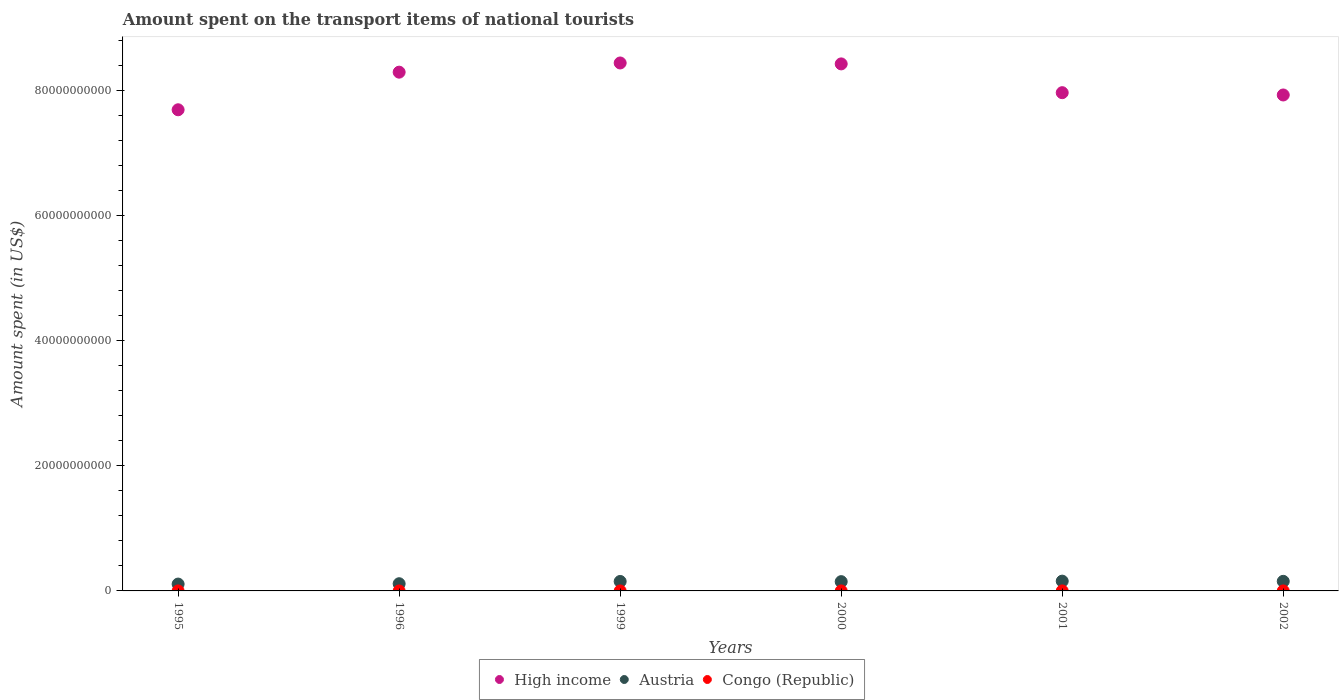How many different coloured dotlines are there?
Provide a short and direct response. 3. What is the amount spent on the transport items of national tourists in Austria in 2001?
Provide a succinct answer. 1.56e+09. Across all years, what is the maximum amount spent on the transport items of national tourists in Congo (Republic)?
Keep it short and to the point. 6.69e+05. Across all years, what is the minimum amount spent on the transport items of national tourists in Austria?
Provide a short and direct response. 1.09e+09. What is the total amount spent on the transport items of national tourists in Austria in the graph?
Your answer should be compact. 8.33e+09. What is the difference between the amount spent on the transport items of national tourists in High income in 1996 and that in 2001?
Your response must be concise. 3.28e+09. What is the difference between the amount spent on the transport items of national tourists in Congo (Republic) in 1999 and the amount spent on the transport items of national tourists in High income in 1996?
Ensure brevity in your answer.  -8.29e+1. What is the average amount spent on the transport items of national tourists in Austria per year?
Ensure brevity in your answer.  1.39e+09. In the year 1999, what is the difference between the amount spent on the transport items of national tourists in Austria and amount spent on the transport items of national tourists in Congo (Republic)?
Make the answer very short. 1.51e+09. What is the ratio of the amount spent on the transport items of national tourists in Austria in 1999 to that in 2000?
Keep it short and to the point. 1.02. What is the difference between the highest and the second highest amount spent on the transport items of national tourists in Congo (Republic)?
Make the answer very short. 6.91e+04. What is the difference between the highest and the lowest amount spent on the transport items of national tourists in High income?
Give a very brief answer. 7.48e+09. Is the sum of the amount spent on the transport items of national tourists in High income in 1996 and 1999 greater than the maximum amount spent on the transport items of national tourists in Congo (Republic) across all years?
Provide a succinct answer. Yes. Is the amount spent on the transport items of national tourists in High income strictly less than the amount spent on the transport items of national tourists in Congo (Republic) over the years?
Offer a terse response. No. Are the values on the major ticks of Y-axis written in scientific E-notation?
Provide a short and direct response. No. Does the graph contain any zero values?
Keep it short and to the point. No. Does the graph contain grids?
Provide a succinct answer. No. Where does the legend appear in the graph?
Make the answer very short. Bottom center. How many legend labels are there?
Ensure brevity in your answer.  3. How are the legend labels stacked?
Provide a short and direct response. Horizontal. What is the title of the graph?
Your answer should be very brief. Amount spent on the transport items of national tourists. Does "Faeroe Islands" appear as one of the legend labels in the graph?
Give a very brief answer. No. What is the label or title of the X-axis?
Provide a succinct answer. Years. What is the label or title of the Y-axis?
Offer a very short reply. Amount spent (in US$). What is the Amount spent (in US$) in High income in 1995?
Ensure brevity in your answer.  7.69e+1. What is the Amount spent (in US$) of Austria in 1995?
Give a very brief answer. 1.09e+09. What is the Amount spent (in US$) of Congo (Republic) in 1995?
Provide a short and direct response. 6.69e+05. What is the Amount spent (in US$) in High income in 1996?
Your answer should be very brief. 8.29e+1. What is the Amount spent (in US$) of Austria in 1996?
Ensure brevity in your answer.  1.15e+09. What is the Amount spent (in US$) of Congo (Republic) in 1996?
Offer a terse response. 1.76e+04. What is the Amount spent (in US$) in High income in 1999?
Keep it short and to the point. 8.44e+1. What is the Amount spent (in US$) of Austria in 1999?
Your response must be concise. 1.51e+09. What is the Amount spent (in US$) of Congo (Republic) in 1999?
Offer a terse response. 5.00e+05. What is the Amount spent (in US$) in High income in 2000?
Give a very brief answer. 8.42e+1. What is the Amount spent (in US$) in Austria in 2000?
Keep it short and to the point. 1.48e+09. What is the Amount spent (in US$) of High income in 2001?
Your answer should be very brief. 7.96e+1. What is the Amount spent (in US$) of Austria in 2001?
Offer a very short reply. 1.56e+09. What is the Amount spent (in US$) of Congo (Republic) in 2001?
Ensure brevity in your answer.  6.00e+05. What is the Amount spent (in US$) in High income in 2002?
Your answer should be very brief. 7.93e+1. What is the Amount spent (in US$) in Austria in 2002?
Make the answer very short. 1.53e+09. What is the Amount spent (in US$) in Congo (Republic) in 2002?
Give a very brief answer. 6.00e+05. Across all years, what is the maximum Amount spent (in US$) in High income?
Provide a succinct answer. 8.44e+1. Across all years, what is the maximum Amount spent (in US$) in Austria?
Make the answer very short. 1.56e+09. Across all years, what is the maximum Amount spent (in US$) of Congo (Republic)?
Give a very brief answer. 6.69e+05. Across all years, what is the minimum Amount spent (in US$) in High income?
Ensure brevity in your answer.  7.69e+1. Across all years, what is the minimum Amount spent (in US$) of Austria?
Keep it short and to the point. 1.09e+09. Across all years, what is the minimum Amount spent (in US$) of Congo (Republic)?
Your response must be concise. 1.76e+04. What is the total Amount spent (in US$) in High income in the graph?
Keep it short and to the point. 4.87e+11. What is the total Amount spent (in US$) of Austria in the graph?
Keep it short and to the point. 8.33e+09. What is the total Amount spent (in US$) of Congo (Republic) in the graph?
Keep it short and to the point. 2.79e+06. What is the difference between the Amount spent (in US$) of High income in 1995 and that in 1996?
Offer a terse response. -6.01e+09. What is the difference between the Amount spent (in US$) of Austria in 1995 and that in 1996?
Give a very brief answer. -5.60e+07. What is the difference between the Amount spent (in US$) in Congo (Republic) in 1995 and that in 1996?
Your response must be concise. 6.52e+05. What is the difference between the Amount spent (in US$) in High income in 1995 and that in 1999?
Keep it short and to the point. -7.48e+09. What is the difference between the Amount spent (in US$) of Austria in 1995 and that in 1999?
Give a very brief answer. -4.17e+08. What is the difference between the Amount spent (in US$) in Congo (Republic) in 1995 and that in 1999?
Provide a short and direct response. 1.69e+05. What is the difference between the Amount spent (in US$) of High income in 1995 and that in 2000?
Your response must be concise. -7.33e+09. What is the difference between the Amount spent (in US$) of Austria in 1995 and that in 2000?
Your response must be concise. -3.89e+08. What is the difference between the Amount spent (in US$) of Congo (Republic) in 1995 and that in 2000?
Your answer should be compact. 2.69e+05. What is the difference between the Amount spent (in US$) in High income in 1995 and that in 2001?
Give a very brief answer. -2.73e+09. What is the difference between the Amount spent (in US$) of Austria in 1995 and that in 2001?
Your answer should be very brief. -4.69e+08. What is the difference between the Amount spent (in US$) in Congo (Republic) in 1995 and that in 2001?
Keep it short and to the point. 6.91e+04. What is the difference between the Amount spent (in US$) of High income in 1995 and that in 2002?
Offer a terse response. -2.36e+09. What is the difference between the Amount spent (in US$) in Austria in 1995 and that in 2002?
Give a very brief answer. -4.37e+08. What is the difference between the Amount spent (in US$) in Congo (Republic) in 1995 and that in 2002?
Offer a very short reply. 6.91e+04. What is the difference between the Amount spent (in US$) of High income in 1996 and that in 1999?
Make the answer very short. -1.47e+09. What is the difference between the Amount spent (in US$) of Austria in 1996 and that in 1999?
Your answer should be compact. -3.61e+08. What is the difference between the Amount spent (in US$) in Congo (Republic) in 1996 and that in 1999?
Your response must be concise. -4.82e+05. What is the difference between the Amount spent (in US$) of High income in 1996 and that in 2000?
Offer a terse response. -1.32e+09. What is the difference between the Amount spent (in US$) of Austria in 1996 and that in 2000?
Offer a very short reply. -3.33e+08. What is the difference between the Amount spent (in US$) of Congo (Republic) in 1996 and that in 2000?
Offer a terse response. -3.82e+05. What is the difference between the Amount spent (in US$) of High income in 1996 and that in 2001?
Keep it short and to the point. 3.28e+09. What is the difference between the Amount spent (in US$) in Austria in 1996 and that in 2001?
Provide a short and direct response. -4.13e+08. What is the difference between the Amount spent (in US$) of Congo (Republic) in 1996 and that in 2001?
Your response must be concise. -5.82e+05. What is the difference between the Amount spent (in US$) in High income in 1996 and that in 2002?
Provide a succinct answer. 3.65e+09. What is the difference between the Amount spent (in US$) of Austria in 1996 and that in 2002?
Keep it short and to the point. -3.81e+08. What is the difference between the Amount spent (in US$) in Congo (Republic) in 1996 and that in 2002?
Make the answer very short. -5.82e+05. What is the difference between the Amount spent (in US$) of High income in 1999 and that in 2000?
Your response must be concise. 1.47e+08. What is the difference between the Amount spent (in US$) of Austria in 1999 and that in 2000?
Make the answer very short. 2.80e+07. What is the difference between the Amount spent (in US$) of Congo (Republic) in 1999 and that in 2000?
Offer a very short reply. 1.00e+05. What is the difference between the Amount spent (in US$) of High income in 1999 and that in 2001?
Your response must be concise. 4.75e+09. What is the difference between the Amount spent (in US$) in Austria in 1999 and that in 2001?
Offer a very short reply. -5.20e+07. What is the difference between the Amount spent (in US$) in High income in 1999 and that in 2002?
Your response must be concise. 5.11e+09. What is the difference between the Amount spent (in US$) in Austria in 1999 and that in 2002?
Your response must be concise. -2.00e+07. What is the difference between the Amount spent (in US$) in High income in 2000 and that in 2001?
Your answer should be compact. 4.60e+09. What is the difference between the Amount spent (in US$) of Austria in 2000 and that in 2001?
Your response must be concise. -8.00e+07. What is the difference between the Amount spent (in US$) in High income in 2000 and that in 2002?
Offer a very short reply. 4.97e+09. What is the difference between the Amount spent (in US$) of Austria in 2000 and that in 2002?
Provide a succinct answer. -4.80e+07. What is the difference between the Amount spent (in US$) in High income in 2001 and that in 2002?
Offer a terse response. 3.67e+08. What is the difference between the Amount spent (in US$) of Austria in 2001 and that in 2002?
Give a very brief answer. 3.20e+07. What is the difference between the Amount spent (in US$) of Congo (Republic) in 2001 and that in 2002?
Ensure brevity in your answer.  0. What is the difference between the Amount spent (in US$) in High income in 1995 and the Amount spent (in US$) in Austria in 1996?
Make the answer very short. 7.57e+1. What is the difference between the Amount spent (in US$) of High income in 1995 and the Amount spent (in US$) of Congo (Republic) in 1996?
Offer a very short reply. 7.69e+1. What is the difference between the Amount spent (in US$) of Austria in 1995 and the Amount spent (in US$) of Congo (Republic) in 1996?
Your answer should be very brief. 1.09e+09. What is the difference between the Amount spent (in US$) of High income in 1995 and the Amount spent (in US$) of Austria in 1999?
Offer a terse response. 7.54e+1. What is the difference between the Amount spent (in US$) in High income in 1995 and the Amount spent (in US$) in Congo (Republic) in 1999?
Ensure brevity in your answer.  7.69e+1. What is the difference between the Amount spent (in US$) in Austria in 1995 and the Amount spent (in US$) in Congo (Republic) in 1999?
Keep it short and to the point. 1.09e+09. What is the difference between the Amount spent (in US$) in High income in 1995 and the Amount spent (in US$) in Austria in 2000?
Your response must be concise. 7.54e+1. What is the difference between the Amount spent (in US$) in High income in 1995 and the Amount spent (in US$) in Congo (Republic) in 2000?
Your answer should be compact. 7.69e+1. What is the difference between the Amount spent (in US$) in Austria in 1995 and the Amount spent (in US$) in Congo (Republic) in 2000?
Your response must be concise. 1.09e+09. What is the difference between the Amount spent (in US$) of High income in 1995 and the Amount spent (in US$) of Austria in 2001?
Keep it short and to the point. 7.53e+1. What is the difference between the Amount spent (in US$) in High income in 1995 and the Amount spent (in US$) in Congo (Republic) in 2001?
Your answer should be very brief. 7.69e+1. What is the difference between the Amount spent (in US$) in Austria in 1995 and the Amount spent (in US$) in Congo (Republic) in 2001?
Provide a short and direct response. 1.09e+09. What is the difference between the Amount spent (in US$) in High income in 1995 and the Amount spent (in US$) in Austria in 2002?
Your answer should be very brief. 7.54e+1. What is the difference between the Amount spent (in US$) in High income in 1995 and the Amount spent (in US$) in Congo (Republic) in 2002?
Your answer should be compact. 7.69e+1. What is the difference between the Amount spent (in US$) of Austria in 1995 and the Amount spent (in US$) of Congo (Republic) in 2002?
Make the answer very short. 1.09e+09. What is the difference between the Amount spent (in US$) of High income in 1996 and the Amount spent (in US$) of Austria in 1999?
Your answer should be compact. 8.14e+1. What is the difference between the Amount spent (in US$) of High income in 1996 and the Amount spent (in US$) of Congo (Republic) in 1999?
Offer a terse response. 8.29e+1. What is the difference between the Amount spent (in US$) in Austria in 1996 and the Amount spent (in US$) in Congo (Republic) in 1999?
Ensure brevity in your answer.  1.15e+09. What is the difference between the Amount spent (in US$) in High income in 1996 and the Amount spent (in US$) in Austria in 2000?
Provide a short and direct response. 8.14e+1. What is the difference between the Amount spent (in US$) in High income in 1996 and the Amount spent (in US$) in Congo (Republic) in 2000?
Make the answer very short. 8.29e+1. What is the difference between the Amount spent (in US$) in Austria in 1996 and the Amount spent (in US$) in Congo (Republic) in 2000?
Give a very brief answer. 1.15e+09. What is the difference between the Amount spent (in US$) of High income in 1996 and the Amount spent (in US$) of Austria in 2001?
Provide a succinct answer. 8.13e+1. What is the difference between the Amount spent (in US$) in High income in 1996 and the Amount spent (in US$) in Congo (Republic) in 2001?
Provide a succinct answer. 8.29e+1. What is the difference between the Amount spent (in US$) of Austria in 1996 and the Amount spent (in US$) of Congo (Republic) in 2001?
Offer a very short reply. 1.15e+09. What is the difference between the Amount spent (in US$) in High income in 1996 and the Amount spent (in US$) in Austria in 2002?
Your answer should be very brief. 8.14e+1. What is the difference between the Amount spent (in US$) of High income in 1996 and the Amount spent (in US$) of Congo (Republic) in 2002?
Provide a short and direct response. 8.29e+1. What is the difference between the Amount spent (in US$) in Austria in 1996 and the Amount spent (in US$) in Congo (Republic) in 2002?
Offer a terse response. 1.15e+09. What is the difference between the Amount spent (in US$) in High income in 1999 and the Amount spent (in US$) in Austria in 2000?
Ensure brevity in your answer.  8.29e+1. What is the difference between the Amount spent (in US$) of High income in 1999 and the Amount spent (in US$) of Congo (Republic) in 2000?
Provide a short and direct response. 8.44e+1. What is the difference between the Amount spent (in US$) in Austria in 1999 and the Amount spent (in US$) in Congo (Republic) in 2000?
Your answer should be very brief. 1.51e+09. What is the difference between the Amount spent (in US$) of High income in 1999 and the Amount spent (in US$) of Austria in 2001?
Give a very brief answer. 8.28e+1. What is the difference between the Amount spent (in US$) of High income in 1999 and the Amount spent (in US$) of Congo (Republic) in 2001?
Your answer should be very brief. 8.44e+1. What is the difference between the Amount spent (in US$) in Austria in 1999 and the Amount spent (in US$) in Congo (Republic) in 2001?
Your answer should be compact. 1.51e+09. What is the difference between the Amount spent (in US$) of High income in 1999 and the Amount spent (in US$) of Austria in 2002?
Offer a terse response. 8.28e+1. What is the difference between the Amount spent (in US$) in High income in 1999 and the Amount spent (in US$) in Congo (Republic) in 2002?
Keep it short and to the point. 8.44e+1. What is the difference between the Amount spent (in US$) of Austria in 1999 and the Amount spent (in US$) of Congo (Republic) in 2002?
Ensure brevity in your answer.  1.51e+09. What is the difference between the Amount spent (in US$) in High income in 2000 and the Amount spent (in US$) in Austria in 2001?
Ensure brevity in your answer.  8.27e+1. What is the difference between the Amount spent (in US$) of High income in 2000 and the Amount spent (in US$) of Congo (Republic) in 2001?
Ensure brevity in your answer.  8.42e+1. What is the difference between the Amount spent (in US$) in Austria in 2000 and the Amount spent (in US$) in Congo (Republic) in 2001?
Offer a very short reply. 1.48e+09. What is the difference between the Amount spent (in US$) of High income in 2000 and the Amount spent (in US$) of Austria in 2002?
Offer a very short reply. 8.27e+1. What is the difference between the Amount spent (in US$) of High income in 2000 and the Amount spent (in US$) of Congo (Republic) in 2002?
Your answer should be very brief. 8.42e+1. What is the difference between the Amount spent (in US$) in Austria in 2000 and the Amount spent (in US$) in Congo (Republic) in 2002?
Ensure brevity in your answer.  1.48e+09. What is the difference between the Amount spent (in US$) of High income in 2001 and the Amount spent (in US$) of Austria in 2002?
Give a very brief answer. 7.81e+1. What is the difference between the Amount spent (in US$) in High income in 2001 and the Amount spent (in US$) in Congo (Republic) in 2002?
Give a very brief answer. 7.96e+1. What is the difference between the Amount spent (in US$) of Austria in 2001 and the Amount spent (in US$) of Congo (Republic) in 2002?
Give a very brief answer. 1.56e+09. What is the average Amount spent (in US$) of High income per year?
Provide a succinct answer. 8.12e+1. What is the average Amount spent (in US$) of Austria per year?
Offer a terse response. 1.39e+09. What is the average Amount spent (in US$) in Congo (Republic) per year?
Your answer should be compact. 4.64e+05. In the year 1995, what is the difference between the Amount spent (in US$) of High income and Amount spent (in US$) of Austria?
Make the answer very short. 7.58e+1. In the year 1995, what is the difference between the Amount spent (in US$) of High income and Amount spent (in US$) of Congo (Republic)?
Your answer should be very brief. 7.69e+1. In the year 1995, what is the difference between the Amount spent (in US$) in Austria and Amount spent (in US$) in Congo (Republic)?
Keep it short and to the point. 1.09e+09. In the year 1996, what is the difference between the Amount spent (in US$) of High income and Amount spent (in US$) of Austria?
Offer a very short reply. 8.17e+1. In the year 1996, what is the difference between the Amount spent (in US$) in High income and Amount spent (in US$) in Congo (Republic)?
Make the answer very short. 8.29e+1. In the year 1996, what is the difference between the Amount spent (in US$) of Austria and Amount spent (in US$) of Congo (Republic)?
Ensure brevity in your answer.  1.15e+09. In the year 1999, what is the difference between the Amount spent (in US$) of High income and Amount spent (in US$) of Austria?
Ensure brevity in your answer.  8.29e+1. In the year 1999, what is the difference between the Amount spent (in US$) in High income and Amount spent (in US$) in Congo (Republic)?
Your response must be concise. 8.44e+1. In the year 1999, what is the difference between the Amount spent (in US$) in Austria and Amount spent (in US$) in Congo (Republic)?
Offer a very short reply. 1.51e+09. In the year 2000, what is the difference between the Amount spent (in US$) in High income and Amount spent (in US$) in Austria?
Provide a short and direct response. 8.27e+1. In the year 2000, what is the difference between the Amount spent (in US$) in High income and Amount spent (in US$) in Congo (Republic)?
Keep it short and to the point. 8.42e+1. In the year 2000, what is the difference between the Amount spent (in US$) of Austria and Amount spent (in US$) of Congo (Republic)?
Offer a terse response. 1.48e+09. In the year 2001, what is the difference between the Amount spent (in US$) of High income and Amount spent (in US$) of Austria?
Your answer should be compact. 7.81e+1. In the year 2001, what is the difference between the Amount spent (in US$) in High income and Amount spent (in US$) in Congo (Republic)?
Provide a short and direct response. 7.96e+1. In the year 2001, what is the difference between the Amount spent (in US$) of Austria and Amount spent (in US$) of Congo (Republic)?
Ensure brevity in your answer.  1.56e+09. In the year 2002, what is the difference between the Amount spent (in US$) in High income and Amount spent (in US$) in Austria?
Give a very brief answer. 7.77e+1. In the year 2002, what is the difference between the Amount spent (in US$) of High income and Amount spent (in US$) of Congo (Republic)?
Keep it short and to the point. 7.93e+1. In the year 2002, what is the difference between the Amount spent (in US$) in Austria and Amount spent (in US$) in Congo (Republic)?
Offer a terse response. 1.53e+09. What is the ratio of the Amount spent (in US$) in High income in 1995 to that in 1996?
Provide a short and direct response. 0.93. What is the ratio of the Amount spent (in US$) of Austria in 1995 to that in 1996?
Make the answer very short. 0.95. What is the ratio of the Amount spent (in US$) of Congo (Republic) in 1995 to that in 1996?
Make the answer very short. 38.03. What is the ratio of the Amount spent (in US$) of High income in 1995 to that in 1999?
Provide a succinct answer. 0.91. What is the ratio of the Amount spent (in US$) of Austria in 1995 to that in 1999?
Make the answer very short. 0.72. What is the ratio of the Amount spent (in US$) in Congo (Republic) in 1995 to that in 1999?
Offer a very short reply. 1.34. What is the ratio of the Amount spent (in US$) in High income in 1995 to that in 2000?
Keep it short and to the point. 0.91. What is the ratio of the Amount spent (in US$) of Austria in 1995 to that in 2000?
Your answer should be compact. 0.74. What is the ratio of the Amount spent (in US$) of Congo (Republic) in 1995 to that in 2000?
Your answer should be very brief. 1.67. What is the ratio of the Amount spent (in US$) of High income in 1995 to that in 2001?
Your answer should be compact. 0.97. What is the ratio of the Amount spent (in US$) of Austria in 1995 to that in 2001?
Your answer should be compact. 0.7. What is the ratio of the Amount spent (in US$) of Congo (Republic) in 1995 to that in 2001?
Your answer should be very brief. 1.12. What is the ratio of the Amount spent (in US$) of High income in 1995 to that in 2002?
Your answer should be compact. 0.97. What is the ratio of the Amount spent (in US$) in Austria in 1995 to that in 2002?
Your response must be concise. 0.71. What is the ratio of the Amount spent (in US$) in Congo (Republic) in 1995 to that in 2002?
Keep it short and to the point. 1.12. What is the ratio of the Amount spent (in US$) in High income in 1996 to that in 1999?
Ensure brevity in your answer.  0.98. What is the ratio of the Amount spent (in US$) in Austria in 1996 to that in 1999?
Ensure brevity in your answer.  0.76. What is the ratio of the Amount spent (in US$) in Congo (Republic) in 1996 to that in 1999?
Provide a short and direct response. 0.04. What is the ratio of the Amount spent (in US$) of High income in 1996 to that in 2000?
Offer a very short reply. 0.98. What is the ratio of the Amount spent (in US$) in Austria in 1996 to that in 2000?
Your answer should be very brief. 0.78. What is the ratio of the Amount spent (in US$) of Congo (Republic) in 1996 to that in 2000?
Your answer should be very brief. 0.04. What is the ratio of the Amount spent (in US$) in High income in 1996 to that in 2001?
Keep it short and to the point. 1.04. What is the ratio of the Amount spent (in US$) in Austria in 1996 to that in 2001?
Your response must be concise. 0.74. What is the ratio of the Amount spent (in US$) in Congo (Republic) in 1996 to that in 2001?
Offer a very short reply. 0.03. What is the ratio of the Amount spent (in US$) of High income in 1996 to that in 2002?
Your answer should be compact. 1.05. What is the ratio of the Amount spent (in US$) in Austria in 1996 to that in 2002?
Your answer should be very brief. 0.75. What is the ratio of the Amount spent (in US$) in Congo (Republic) in 1996 to that in 2002?
Your answer should be compact. 0.03. What is the ratio of the Amount spent (in US$) in High income in 1999 to that in 2000?
Provide a succinct answer. 1. What is the ratio of the Amount spent (in US$) in Austria in 1999 to that in 2000?
Your response must be concise. 1.02. What is the ratio of the Amount spent (in US$) in High income in 1999 to that in 2001?
Offer a very short reply. 1.06. What is the ratio of the Amount spent (in US$) in Austria in 1999 to that in 2001?
Your answer should be compact. 0.97. What is the ratio of the Amount spent (in US$) in High income in 1999 to that in 2002?
Offer a terse response. 1.06. What is the ratio of the Amount spent (in US$) in Austria in 1999 to that in 2002?
Keep it short and to the point. 0.99. What is the ratio of the Amount spent (in US$) in Congo (Republic) in 1999 to that in 2002?
Your answer should be compact. 0.83. What is the ratio of the Amount spent (in US$) in High income in 2000 to that in 2001?
Keep it short and to the point. 1.06. What is the ratio of the Amount spent (in US$) in Austria in 2000 to that in 2001?
Give a very brief answer. 0.95. What is the ratio of the Amount spent (in US$) in Congo (Republic) in 2000 to that in 2001?
Offer a terse response. 0.67. What is the ratio of the Amount spent (in US$) of High income in 2000 to that in 2002?
Make the answer very short. 1.06. What is the ratio of the Amount spent (in US$) in Austria in 2000 to that in 2002?
Offer a terse response. 0.97. What is the ratio of the Amount spent (in US$) in High income in 2001 to that in 2002?
Provide a short and direct response. 1. What is the ratio of the Amount spent (in US$) in Austria in 2001 to that in 2002?
Your response must be concise. 1.02. What is the difference between the highest and the second highest Amount spent (in US$) in High income?
Make the answer very short. 1.47e+08. What is the difference between the highest and the second highest Amount spent (in US$) of Austria?
Your answer should be compact. 3.20e+07. What is the difference between the highest and the second highest Amount spent (in US$) of Congo (Republic)?
Provide a short and direct response. 6.91e+04. What is the difference between the highest and the lowest Amount spent (in US$) in High income?
Offer a terse response. 7.48e+09. What is the difference between the highest and the lowest Amount spent (in US$) in Austria?
Offer a terse response. 4.69e+08. What is the difference between the highest and the lowest Amount spent (in US$) in Congo (Republic)?
Your response must be concise. 6.52e+05. 